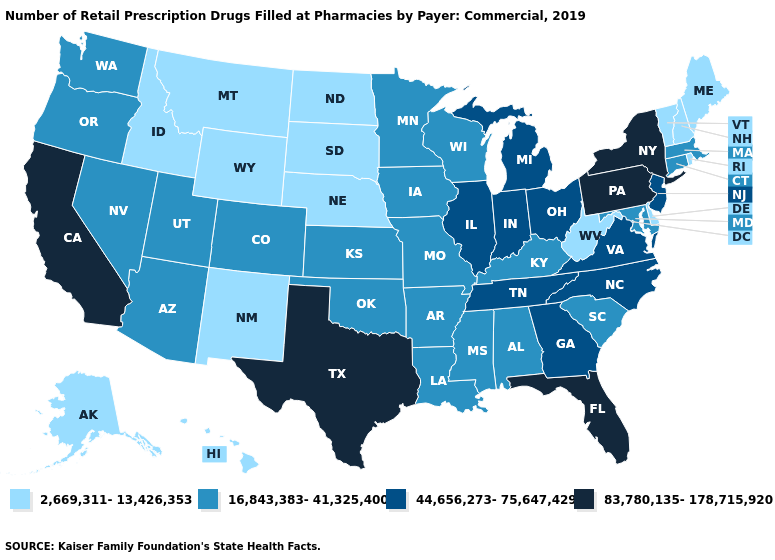Does Hawaii have the lowest value in the West?
Keep it brief. Yes. What is the value of Massachusetts?
Answer briefly. 16,843,383-41,325,400. What is the lowest value in the USA?
Answer briefly. 2,669,311-13,426,353. What is the value of Connecticut?
Write a very short answer. 16,843,383-41,325,400. Name the states that have a value in the range 83,780,135-178,715,920?
Short answer required. California, Florida, New York, Pennsylvania, Texas. Name the states that have a value in the range 16,843,383-41,325,400?
Answer briefly. Alabama, Arizona, Arkansas, Colorado, Connecticut, Iowa, Kansas, Kentucky, Louisiana, Maryland, Massachusetts, Minnesota, Mississippi, Missouri, Nevada, Oklahoma, Oregon, South Carolina, Utah, Washington, Wisconsin. Which states have the highest value in the USA?
Concise answer only. California, Florida, New York, Pennsylvania, Texas. Does Michigan have the lowest value in the MidWest?
Give a very brief answer. No. Name the states that have a value in the range 44,656,273-75,647,429?
Give a very brief answer. Georgia, Illinois, Indiana, Michigan, New Jersey, North Carolina, Ohio, Tennessee, Virginia. Name the states that have a value in the range 2,669,311-13,426,353?
Be succinct. Alaska, Delaware, Hawaii, Idaho, Maine, Montana, Nebraska, New Hampshire, New Mexico, North Dakota, Rhode Island, South Dakota, Vermont, West Virginia, Wyoming. Which states hav the highest value in the South?
Give a very brief answer. Florida, Texas. Does Texas have the same value as California?
Concise answer only. Yes. What is the highest value in states that border Mississippi?
Short answer required. 44,656,273-75,647,429. What is the value of Tennessee?
Quick response, please. 44,656,273-75,647,429. Name the states that have a value in the range 16,843,383-41,325,400?
Write a very short answer. Alabama, Arizona, Arkansas, Colorado, Connecticut, Iowa, Kansas, Kentucky, Louisiana, Maryland, Massachusetts, Minnesota, Mississippi, Missouri, Nevada, Oklahoma, Oregon, South Carolina, Utah, Washington, Wisconsin. 